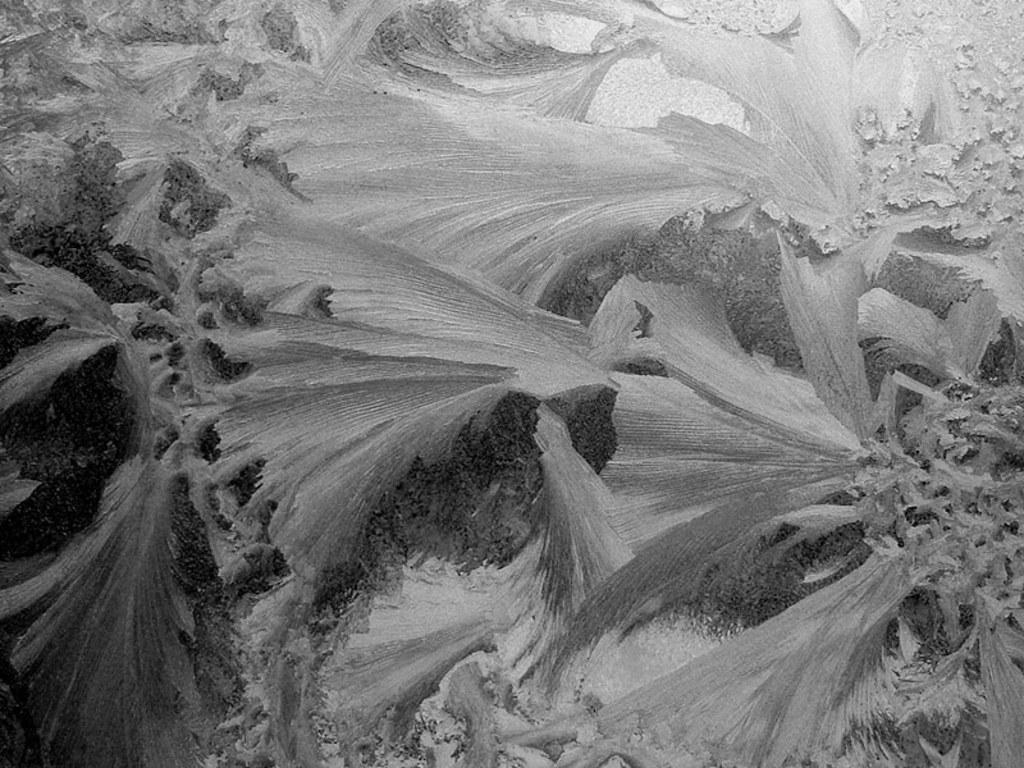What is the color scheme of the picture? The picture is black and white. What type of objects can be seen in the picture? There are plants in the picture. How many apples are hanging from the plants in the picture? There are no apples present in the picture; it only features plants. What type of toad can be seen hopping in the picture? There is no toad present in the picture; it only features plants. 